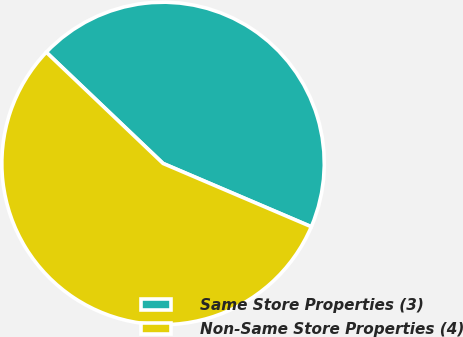<chart> <loc_0><loc_0><loc_500><loc_500><pie_chart><fcel>Same Store Properties (3)<fcel>Non-Same Store Properties (4)<nl><fcel>44.31%<fcel>55.69%<nl></chart> 